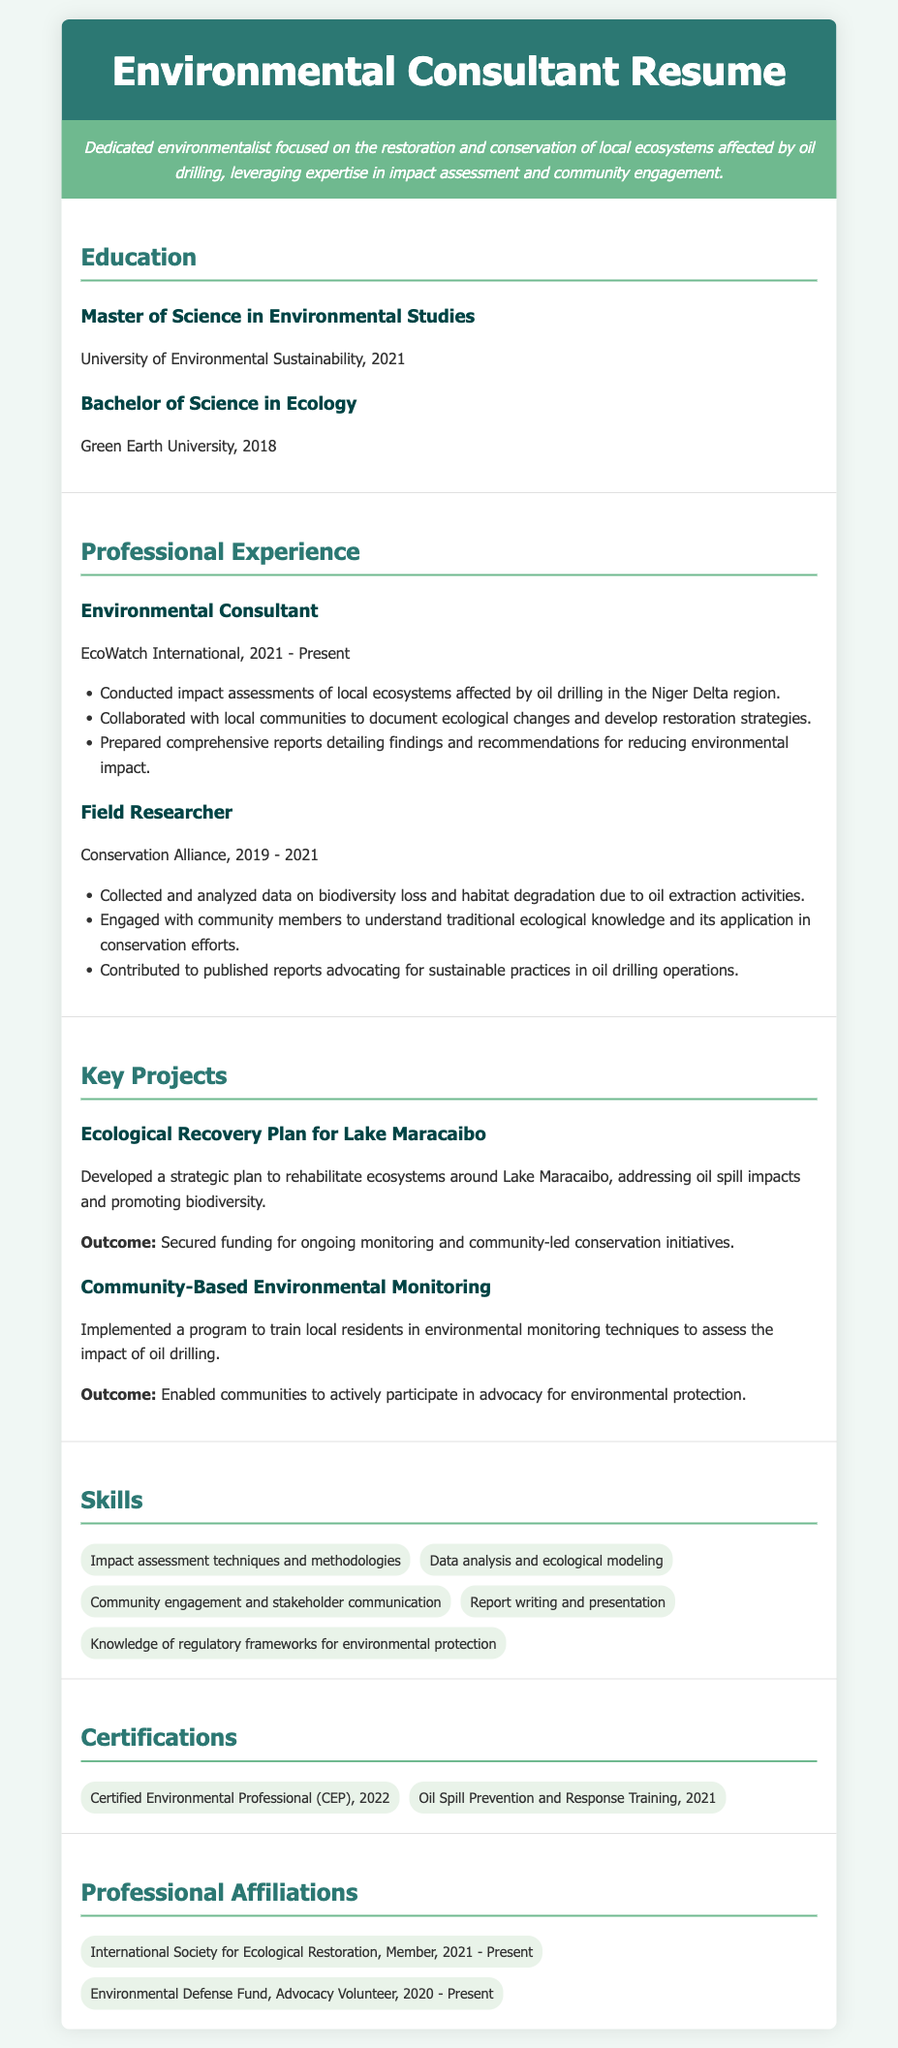What is the title of the resume? The title appears at the top of the resume in a prominent position, indicating the purpose of the document.
Answer: Environmental Consultant Resume What year did the individual complete their Master of Science? The year of completion is listed alongside the degree and institution in the education section.
Answer: 2021 Which organization does the individual currently work for? This information is found under the professional experience section, highlighting the current employment status.
Answer: EcoWatch International What is one outcome of the Ecological Recovery Plan for Lake Maracaibo? Outcomes are stated clearly in the project descriptions, providing evidence of the plan's impact.
Answer: Secured funding for ongoing monitoring In which region did the consultant conduct impact assessments? The geographic focus of the work is specified within the description of the individual's professional experience.
Answer: Niger Delta region What certification did the individual obtain in 2022? Certifications are listed in their own section, detailing the specific credentials earned by the individual.
Answer: Certified Environmental Professional (CEP) How many years was the individual employed as a Field Researcher? The employment dates provide a direct way to calculate the duration of the role in the experience section.
Answer: 2 years What type of training did the individual complete in 2021? This type of training is specified under certifications and gives insight into the individual’s specialization.
Answer: Oil Spill Prevention and Response Training Which organization is the individual a member of since 2021? This question pertains to professional affiliations, highlighting the networks the individual is connected to.
Answer: International Society for Ecological Restoration 